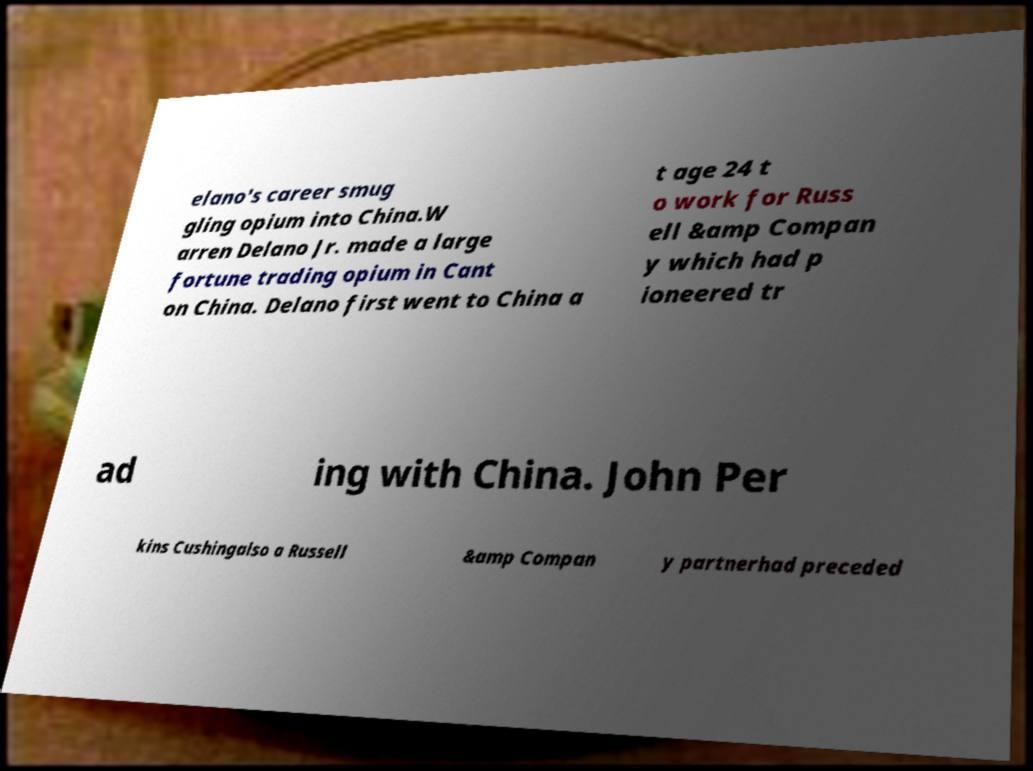There's text embedded in this image that I need extracted. Can you transcribe it verbatim? elano's career smug gling opium into China.W arren Delano Jr. made a large fortune trading opium in Cant on China. Delano first went to China a t age 24 t o work for Russ ell &amp Compan y which had p ioneered tr ad ing with China. John Per kins Cushingalso a Russell &amp Compan y partnerhad preceded 